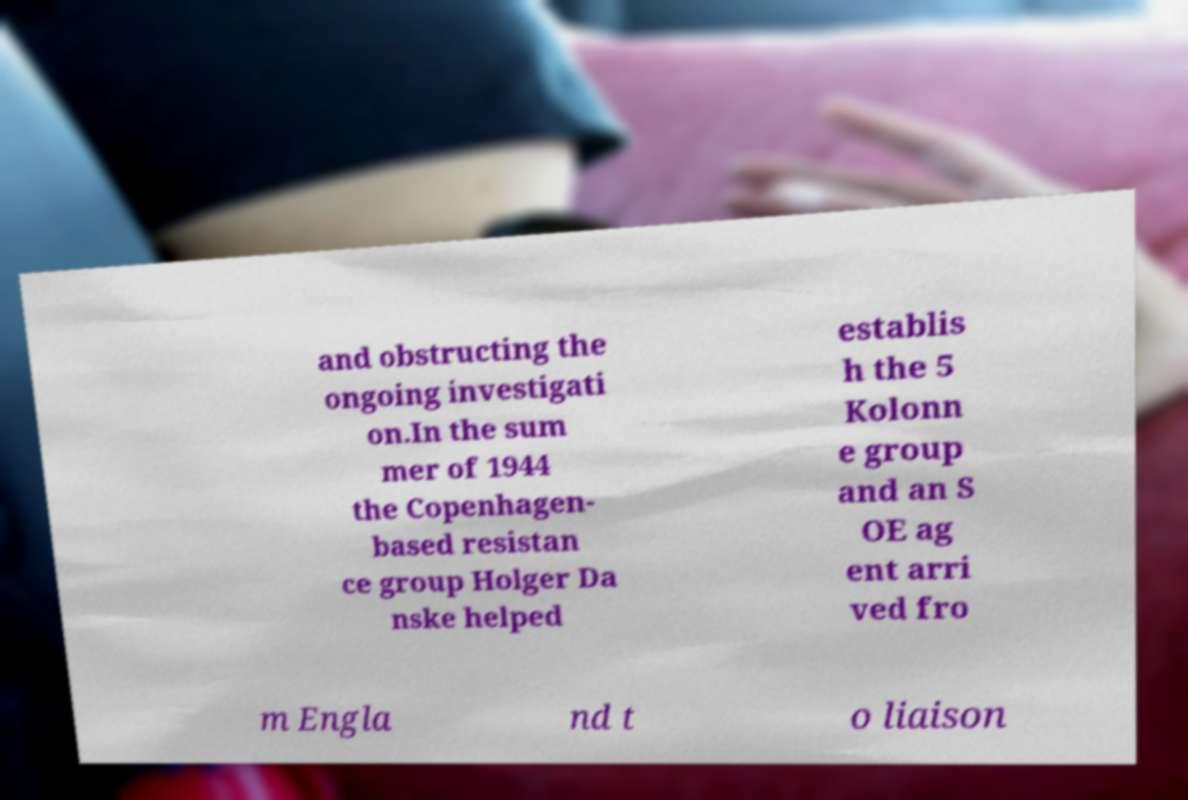Please read and relay the text visible in this image. What does it say? and obstructing the ongoing investigati on.In the sum mer of 1944 the Copenhagen- based resistan ce group Holger Da nske helped establis h the 5 Kolonn e group and an S OE ag ent arri ved fro m Engla nd t o liaison 